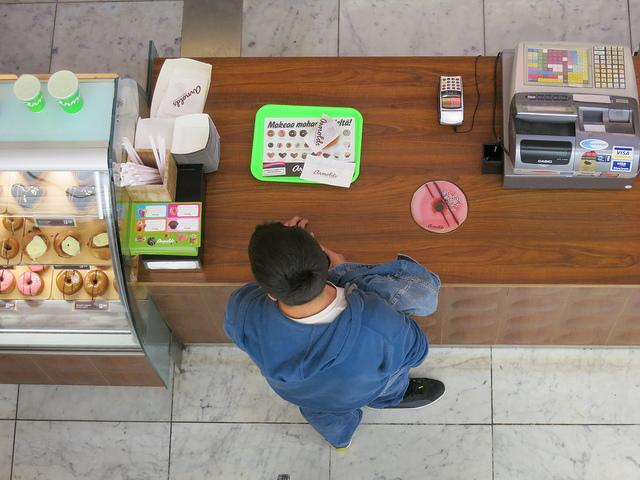Who is the man waiting for? Please explain your reasoning. cashier. He is at the register waiting to make a purchase 